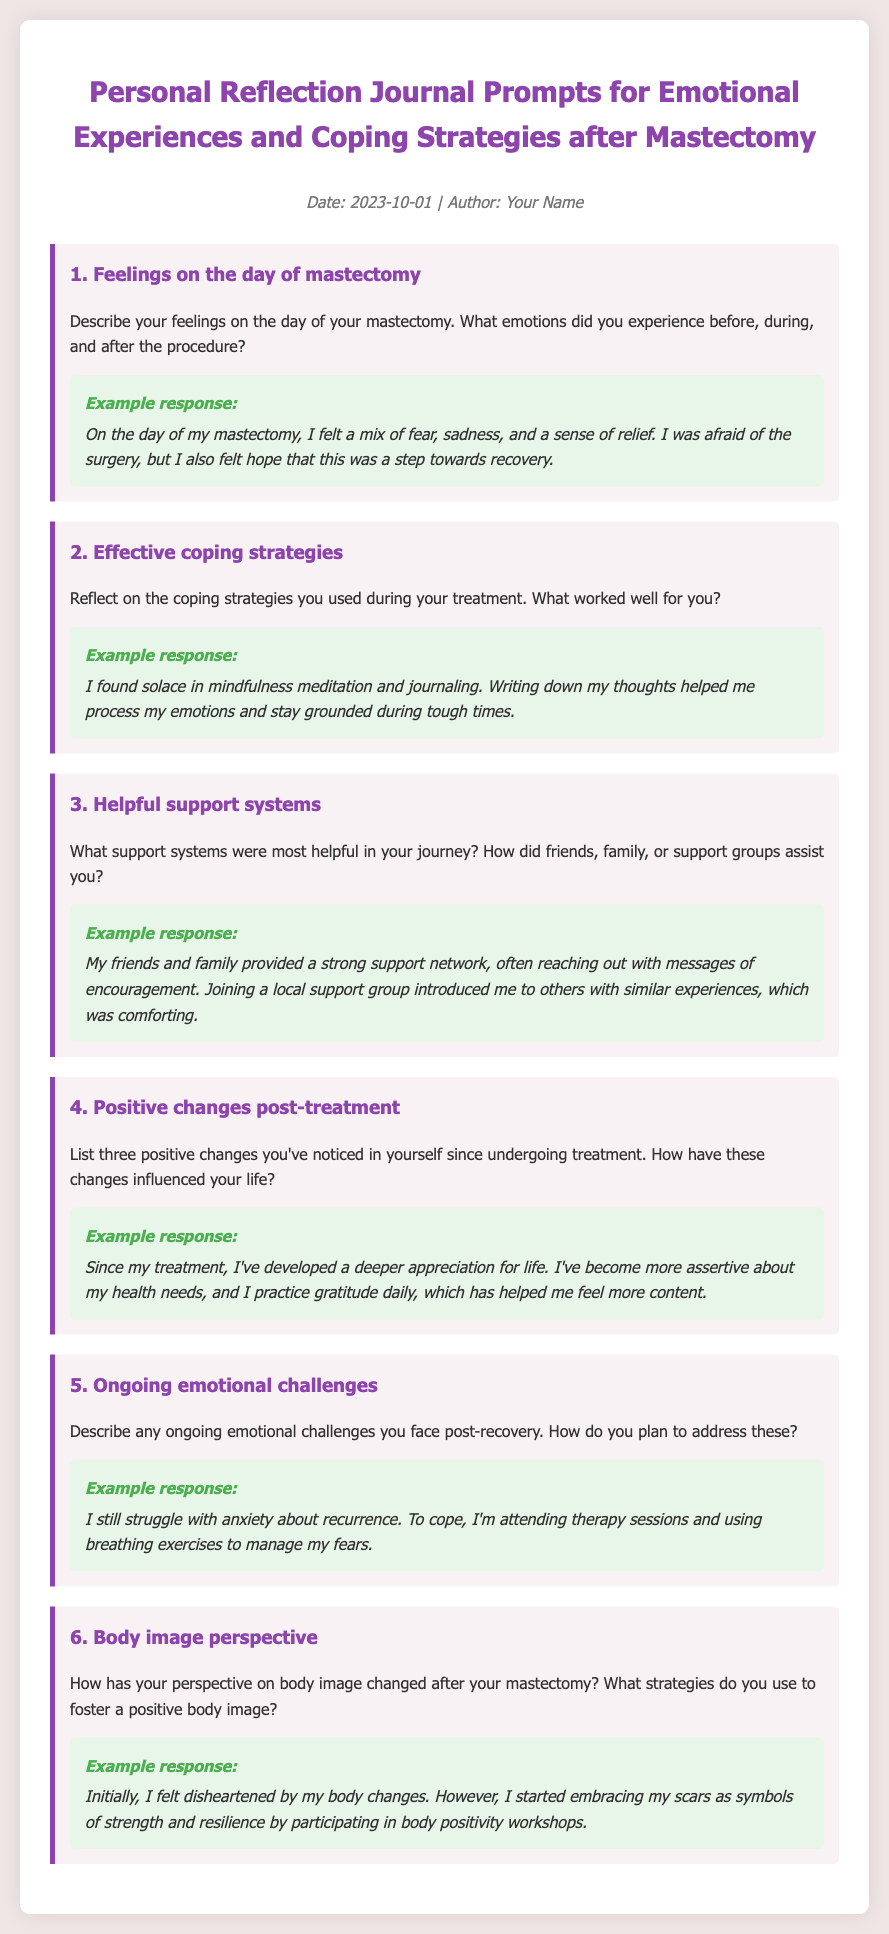What is the title of the document? The title is prominently displayed at the top of the document and summarizes the content.
Answer: Personal Reflection Journal Prompts for Emotional Experiences and Coping Strategies after Mastectomy What date is mentioned in the memo? The date is listed in the metadata section of the document.
Answer: 2023-10-01 How many prompts are included in the document? The number of prompts can be counted in the main body of the document.
Answer: 6 What emotion is mentioned as a feeling on the day of the mastectomy? The prompt asks for emotions experienced on the day of the mastectomy, and one of them is specified in the example response.
Answer: Fear What coping strategy did the author find solace in? The document includes a specific coping strategy mentioned in one of the prompts and its example response.
Answer: Mindfulness meditation What is the color of the prompt background? The background color of the prompts is provided through the styling of the document.
Answer: Light pink How did family assist the survivor according to the document? The support role of family is outlined in one of the example responses under helpful support systems.
Answer: Messages of encouragement What is described as a positive change post-treatment? The document lists changes observed after treatment in the fourth prompt and its example.
Answer: Appreciation for life What ongoing emotional challenge is mentioned? The document points out specific emotional challenges faced post-recovery in one of the prompts.
Answer: Anxiety about recurrence 